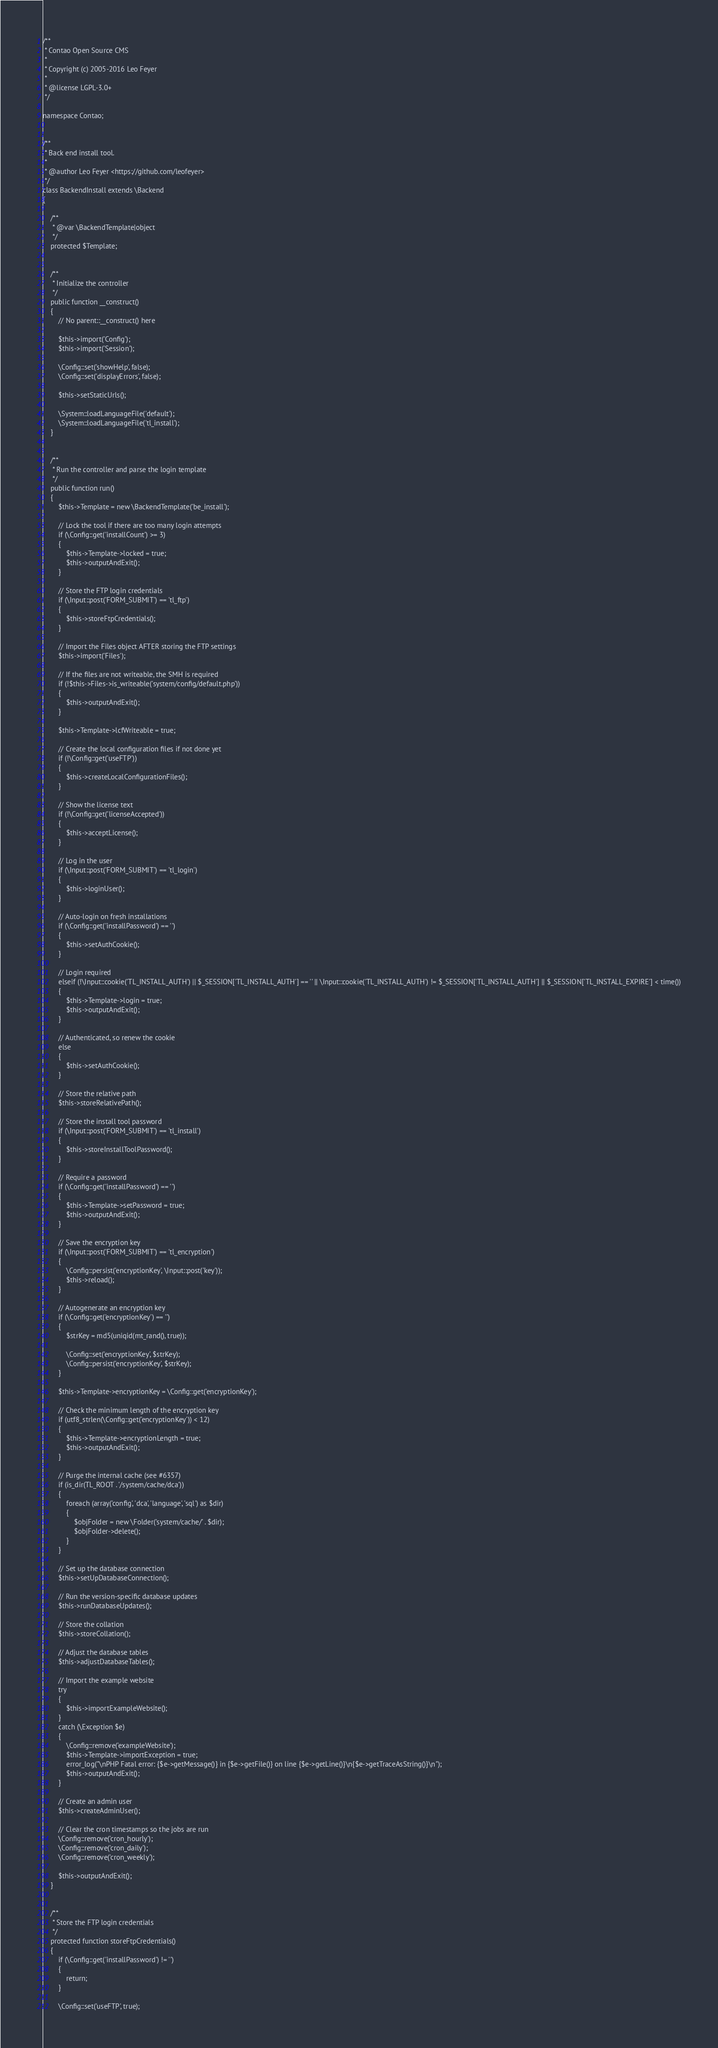Convert code to text. <code><loc_0><loc_0><loc_500><loc_500><_PHP_>/**
 * Contao Open Source CMS
 *
 * Copyright (c) 2005-2016 Leo Feyer
 *
 * @license LGPL-3.0+
 */

namespace Contao;


/**
 * Back end install tool.
 *
 * @author Leo Feyer <https://github.com/leofeyer>
 */
class BackendInstall extends \Backend
{

	/**
	 * @var \BackendTemplate|object
	 */
	protected $Template;


	/**
	 * Initialize the controller
	 */
	public function __construct()
	{
		// No parent::__construct() here

		$this->import('Config');
		$this->import('Session');

		\Config::set('showHelp', false);
		\Config::set('displayErrors', false);

		$this->setStaticUrls();

		\System::loadLanguageFile('default');
		\System::loadLanguageFile('tl_install');
	}


	/**
	 * Run the controller and parse the login template
	 */
	public function run()
	{
		$this->Template = new \BackendTemplate('be_install');

		// Lock the tool if there are too many login attempts
		if (\Config::get('installCount') >= 3)
		{
			$this->Template->locked = true;
			$this->outputAndExit();
		}

		// Store the FTP login credentials
		if (\Input::post('FORM_SUBMIT') == 'tl_ftp')
		{
			$this->storeFtpCredentials();
		}

		// Import the Files object AFTER storing the FTP settings
		$this->import('Files');

		// If the files are not writeable, the SMH is required
		if (!$this->Files->is_writeable('system/config/default.php'))
		{
			$this->outputAndExit();
		}

		$this->Template->lcfWriteable = true;

		// Create the local configuration files if not done yet
		if (!\Config::get('useFTP'))
		{
			$this->createLocalConfigurationFiles();
		}

		// Show the license text
		if (!\Config::get('licenseAccepted'))
		{
			$this->acceptLicense();
		}

		// Log in the user
		if (\Input::post('FORM_SUBMIT') == 'tl_login')
		{
			$this->loginUser();
		}

		// Auto-login on fresh installations
		if (\Config::get('installPassword') == '')
		{
			$this->setAuthCookie();
		}

		// Login required
		elseif (!\Input::cookie('TL_INSTALL_AUTH') || $_SESSION['TL_INSTALL_AUTH'] == '' || \Input::cookie('TL_INSTALL_AUTH') != $_SESSION['TL_INSTALL_AUTH'] || $_SESSION['TL_INSTALL_EXPIRE'] < time())
		{
			$this->Template->login = true;
			$this->outputAndExit();
		}

		// Authenticated, so renew the cookie
		else
		{
			$this->setAuthCookie();
		}

		// Store the relative path
		$this->storeRelativePath();

		// Store the install tool password
		if (\Input::post('FORM_SUBMIT') == 'tl_install')
		{
			$this->storeInstallToolPassword();
		}

		// Require a password
		if (\Config::get('installPassword') == '')
		{
			$this->Template->setPassword = true;
			$this->outputAndExit();
		}

		// Save the encryption key
		if (\Input::post('FORM_SUBMIT') == 'tl_encryption')
		{
			\Config::persist('encryptionKey', \Input::post('key'));
			$this->reload();
		}

		// Autogenerate an encryption key
		if (\Config::get('encryptionKey') == '')
		{
			$strKey = md5(uniqid(mt_rand(), true));

			\Config::set('encryptionKey', $strKey);
			\Config::persist('encryptionKey', $strKey);
		}

		$this->Template->encryptionKey = \Config::get('encryptionKey');

		// Check the minimum length of the encryption key
		if (utf8_strlen(\Config::get('encryptionKey')) < 12)
		{
			$this->Template->encryptionLength = true;
			$this->outputAndExit();
		}

		// Purge the internal cache (see #6357)
		if (is_dir(TL_ROOT . '/system/cache/dca'))
		{
			foreach (array('config', 'dca', 'language', 'sql') as $dir)
			{
				$objFolder = new \Folder('system/cache/' . $dir);
				$objFolder->delete();
			}
		}

		// Set up the database connection
		$this->setUpDatabaseConnection();

		// Run the version-specific database updates
		$this->runDatabaseUpdates();

		// Store the collation
		$this->storeCollation();

		// Adjust the database tables
		$this->adjustDatabaseTables();

		// Import the example website
		try
		{
			$this->importExampleWebsite();
		}
		catch (\Exception $e)
		{
			\Config::remove('exampleWebsite');
			$this->Template->importException = true;
			error_log("\nPHP Fatal error: {$e->getMessage()} in {$e->getFile()} on line {$e->getLine()}\n{$e->getTraceAsString()}\n");
			$this->outputAndExit();
		}

		// Create an admin user
		$this->createAdminUser();

		// Clear the cron timestamps so the jobs are run
		\Config::remove('cron_hourly');
		\Config::remove('cron_daily');
		\Config::remove('cron_weekly');

		$this->outputAndExit();
	}


	/**
	 * Store the FTP login credentials
	 */
	protected function storeFtpCredentials()
	{
		if (\Config::get('installPassword') != '')
		{
			return;
		}

		\Config::set('useFTP', true);</code> 